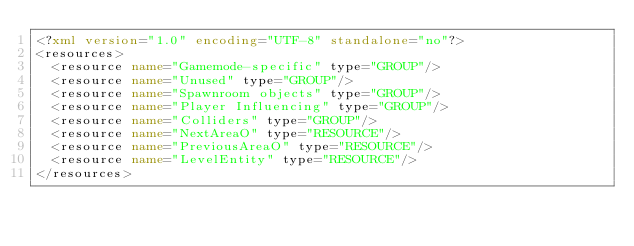Convert code to text. <code><loc_0><loc_0><loc_500><loc_500><_XML_><?xml version="1.0" encoding="UTF-8" standalone="no"?>
<resources>
  <resource name="Gamemode-specific" type="GROUP"/>
  <resource name="Unused" type="GROUP"/>
  <resource name="Spawnroom objects" type="GROUP"/>
  <resource name="Player Influencing" type="GROUP"/>
  <resource name="Colliders" type="GROUP"/>
  <resource name="NextAreaO" type="RESOURCE"/>
  <resource name="PreviousAreaO" type="RESOURCE"/>
  <resource name="LevelEntity" type="RESOURCE"/>
</resources>
</code> 